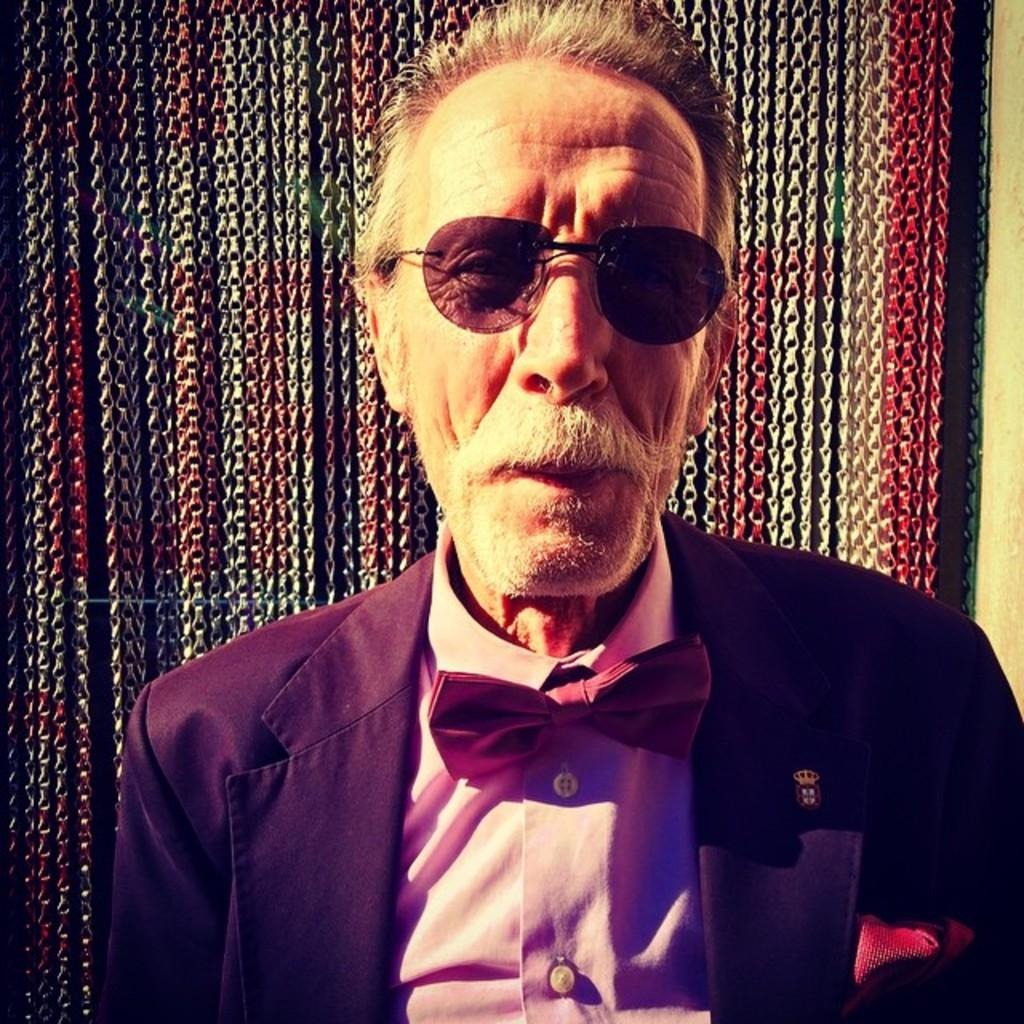What is the main subject of the image? The main subject of the image is a man. Can you describe any facial hair on the man? Yes, the man has a mustache and a beard. What type of clothing is the man wearing? The man is wearing a blazer. What type of eyewear is the man wearing? The man is wearing goggles. How does the man increase the temperature of the room in the image? There is no information in the image about the man increasing the temperature of the room. What type of soda is the man holding in the image? There is no soda present in the image. 